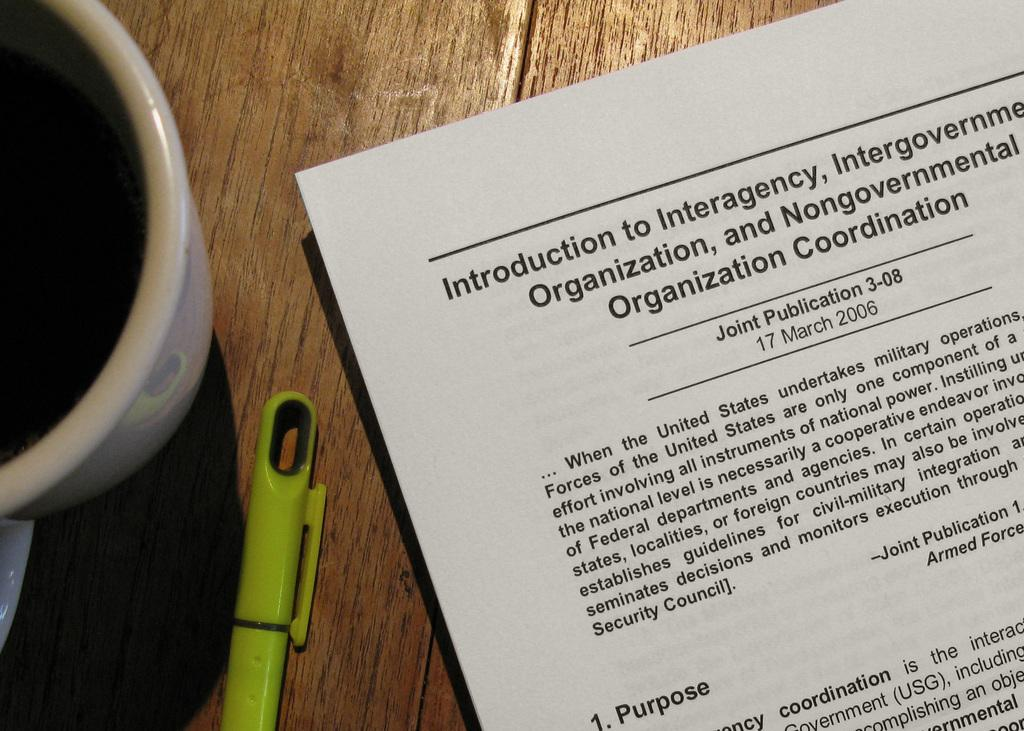What is present on the paper in the image? Something is written on the paper. What can be used to write on the paper? There is a green color pen in the image. What is the color of the cup in the image? There is a white color cup in the image. What is the color of the table in the image? The table in the image is brown. Can you describe the bat that is flying around in the image? There is no bat present in the image; it only mentions a paper, a green color pen, a white color cup, and a brown table. 